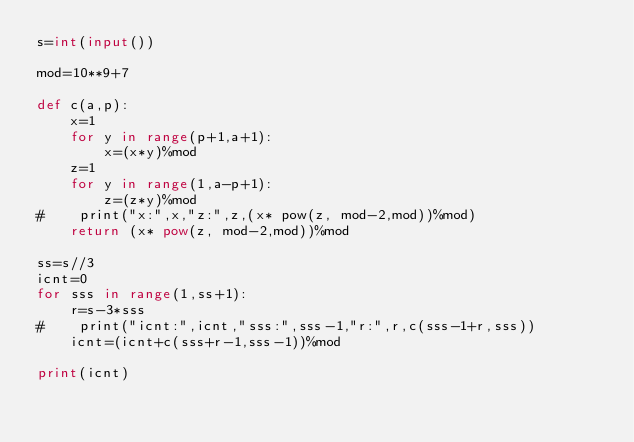Convert code to text. <code><loc_0><loc_0><loc_500><loc_500><_Python_>s=int(input())

mod=10**9+7

def c(a,p):
    x=1
    for y in range(p+1,a+1):
        x=(x*y)%mod
    z=1
    for y in range(1,a-p+1):
        z=(z*y)%mod
#    print("x:",x,"z:",z,(x* pow(z, mod-2,mod))%mod)
    return (x* pow(z, mod-2,mod))%mod    

ss=s//3
icnt=0
for sss in range(1,ss+1):
    r=s-3*sss
#    print("icnt:",icnt,"sss:",sss-1,"r:",r,c(sss-1+r,sss))
    icnt=(icnt+c(sss+r-1,sss-1))%mod

print(icnt)
</code> 